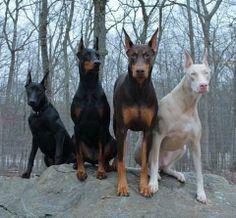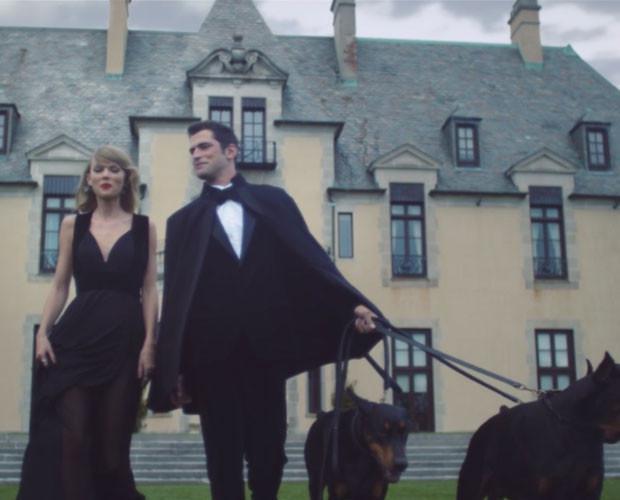The first image is the image on the left, the second image is the image on the right. Assess this claim about the two images: "There are more dogs in the image on the left.". Correct or not? Answer yes or no. Yes. The first image is the image on the left, the second image is the image on the right. For the images shown, is this caption "A person is bending down behind a standing doberman, with one hand holding the front of the dog under its head." true? Answer yes or no. No. 